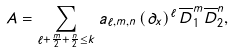Convert formula to latex. <formula><loc_0><loc_0><loc_500><loc_500>A = \sum _ { \ell + \frac { m } { 2 } + \frac { n } { 2 } \leq k } a _ { \ell , m , n } \left ( \partial _ { x } \right ) ^ { \ell } \overline { D } _ { 1 } ^ { m } \overline { D } _ { 2 } ^ { n } ,</formula> 